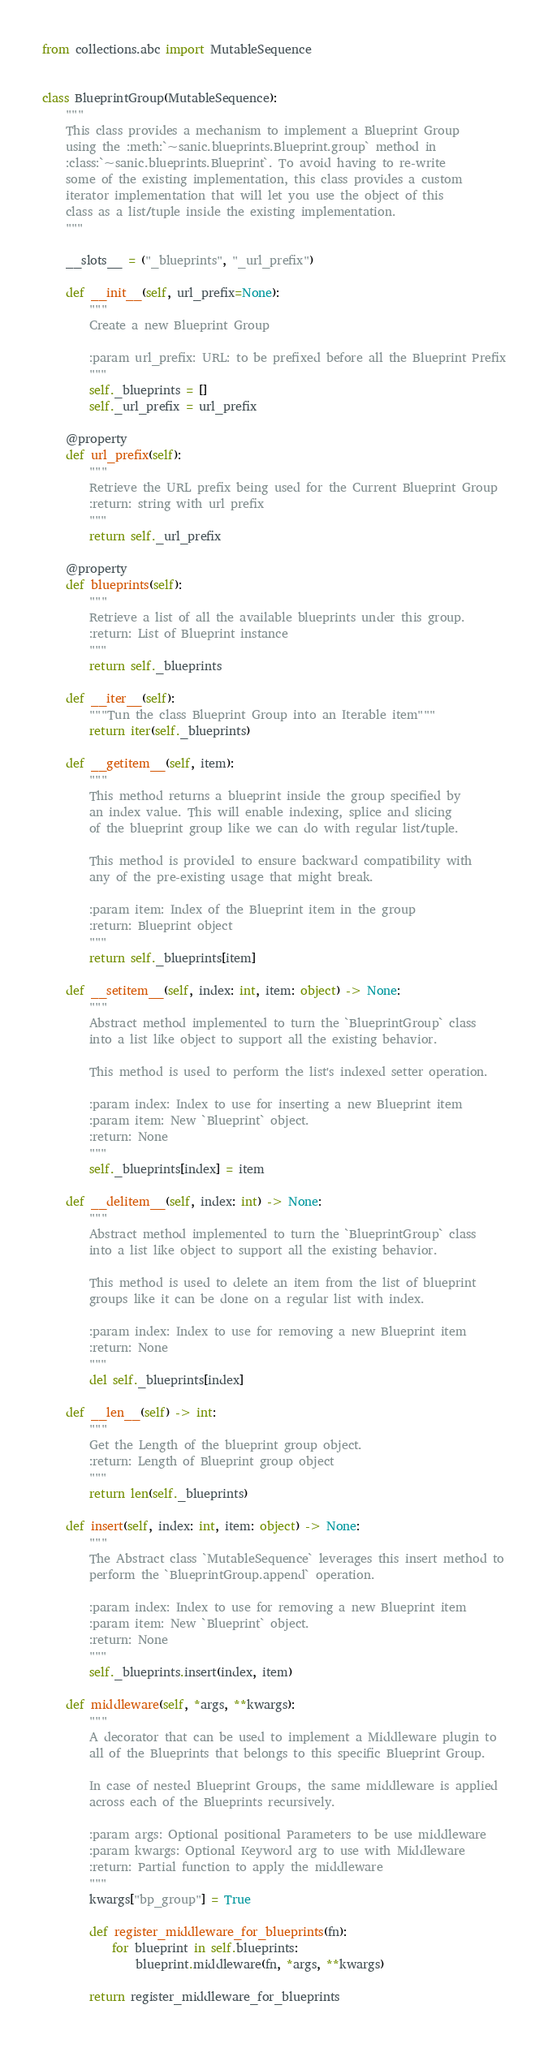Convert code to text. <code><loc_0><loc_0><loc_500><loc_500><_Python_>from collections.abc import MutableSequence


class BlueprintGroup(MutableSequence):
    """
    This class provides a mechanism to implement a Blueprint Group
    using the :meth:`~sanic.blueprints.Blueprint.group` method in
    :class:`~sanic.blueprints.Blueprint`. To avoid having to re-write
    some of the existing implementation, this class provides a custom
    iterator implementation that will let you use the object of this
    class as a list/tuple inside the existing implementation.
    """

    __slots__ = ("_blueprints", "_url_prefix")

    def __init__(self, url_prefix=None):
        """
        Create a new Blueprint Group

        :param url_prefix: URL: to be prefixed before all the Blueprint Prefix
        """
        self._blueprints = []
        self._url_prefix = url_prefix

    @property
    def url_prefix(self):
        """
        Retrieve the URL prefix being used for the Current Blueprint Group
        :return: string with url prefix
        """
        return self._url_prefix

    @property
    def blueprints(self):
        """
        Retrieve a list of all the available blueprints under this group.
        :return: List of Blueprint instance
        """
        return self._blueprints

    def __iter__(self):
        """Tun the class Blueprint Group into an Iterable item"""
        return iter(self._blueprints)

    def __getitem__(self, item):
        """
        This method returns a blueprint inside the group specified by
        an index value. This will enable indexing, splice and slicing
        of the blueprint group like we can do with regular list/tuple.

        This method is provided to ensure backward compatibility with
        any of the pre-existing usage that might break.

        :param item: Index of the Blueprint item in the group
        :return: Blueprint object
        """
        return self._blueprints[item]

    def __setitem__(self, index: int, item: object) -> None:
        """
        Abstract method implemented to turn the `BlueprintGroup` class
        into a list like object to support all the existing behavior.

        This method is used to perform the list's indexed setter operation.

        :param index: Index to use for inserting a new Blueprint item
        :param item: New `Blueprint` object.
        :return: None
        """
        self._blueprints[index] = item

    def __delitem__(self, index: int) -> None:
        """
        Abstract method implemented to turn the `BlueprintGroup` class
        into a list like object to support all the existing behavior.

        This method is used to delete an item from the list of blueprint
        groups like it can be done on a regular list with index.

        :param index: Index to use for removing a new Blueprint item
        :return: None
        """
        del self._blueprints[index]

    def __len__(self) -> int:
        """
        Get the Length of the blueprint group object.
        :return: Length of Blueprint group object
        """
        return len(self._blueprints)

    def insert(self, index: int, item: object) -> None:
        """
        The Abstract class `MutableSequence` leverages this insert method to
        perform the `BlueprintGroup.append` operation.

        :param index: Index to use for removing a new Blueprint item
        :param item: New `Blueprint` object.
        :return: None
        """
        self._blueprints.insert(index, item)

    def middleware(self, *args, **kwargs):
        """
        A decorator that can be used to implement a Middleware plugin to
        all of the Blueprints that belongs to this specific Blueprint Group.

        In case of nested Blueprint Groups, the same middleware is applied
        across each of the Blueprints recursively.

        :param args: Optional positional Parameters to be use middleware
        :param kwargs: Optional Keyword arg to use with Middleware
        :return: Partial function to apply the middleware
        """
        kwargs["bp_group"] = True

        def register_middleware_for_blueprints(fn):
            for blueprint in self.blueprints:
                blueprint.middleware(fn, *args, **kwargs)

        return register_middleware_for_blueprints
</code> 